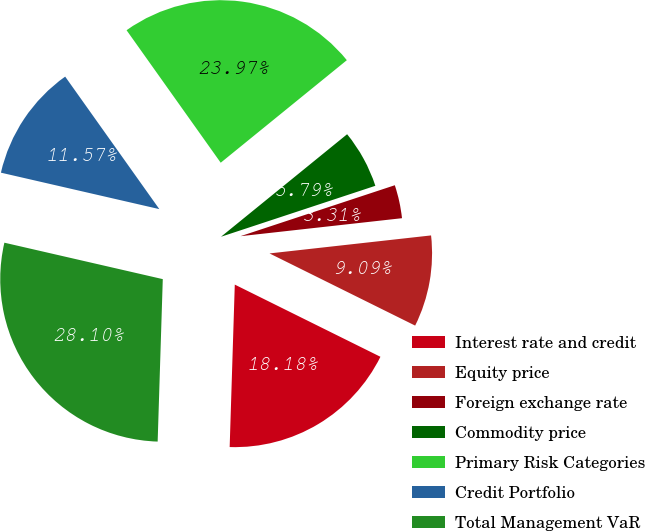Convert chart to OTSL. <chart><loc_0><loc_0><loc_500><loc_500><pie_chart><fcel>Interest rate and credit<fcel>Equity price<fcel>Foreign exchange rate<fcel>Commodity price<fcel>Primary Risk Categories<fcel>Credit Portfolio<fcel>Total Management VaR<nl><fcel>18.18%<fcel>9.09%<fcel>3.31%<fcel>5.79%<fcel>23.97%<fcel>11.57%<fcel>28.1%<nl></chart> 